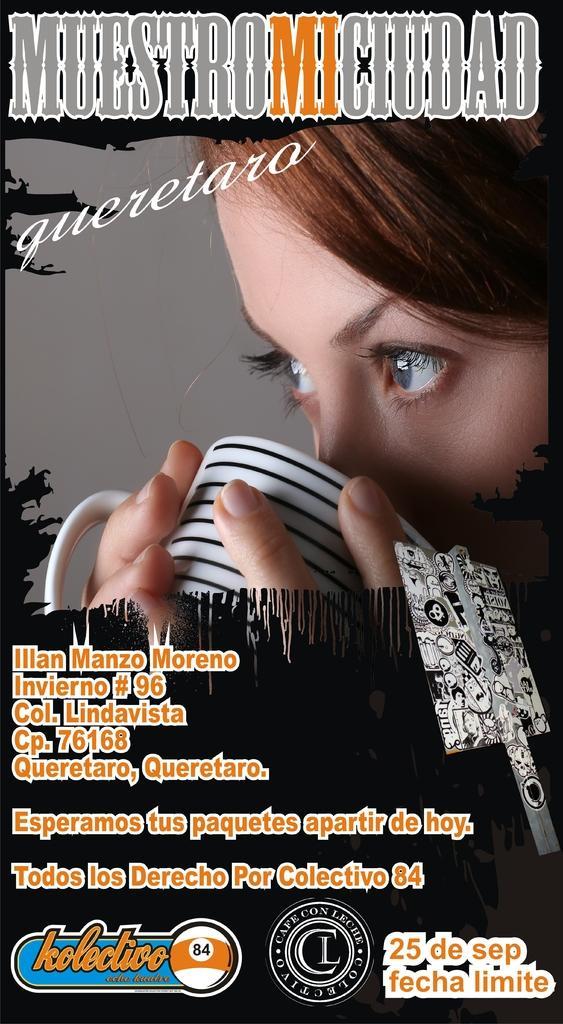In one or two sentences, can you explain what this image depicts? In this image in the front there is text and there is a person holding cup. 